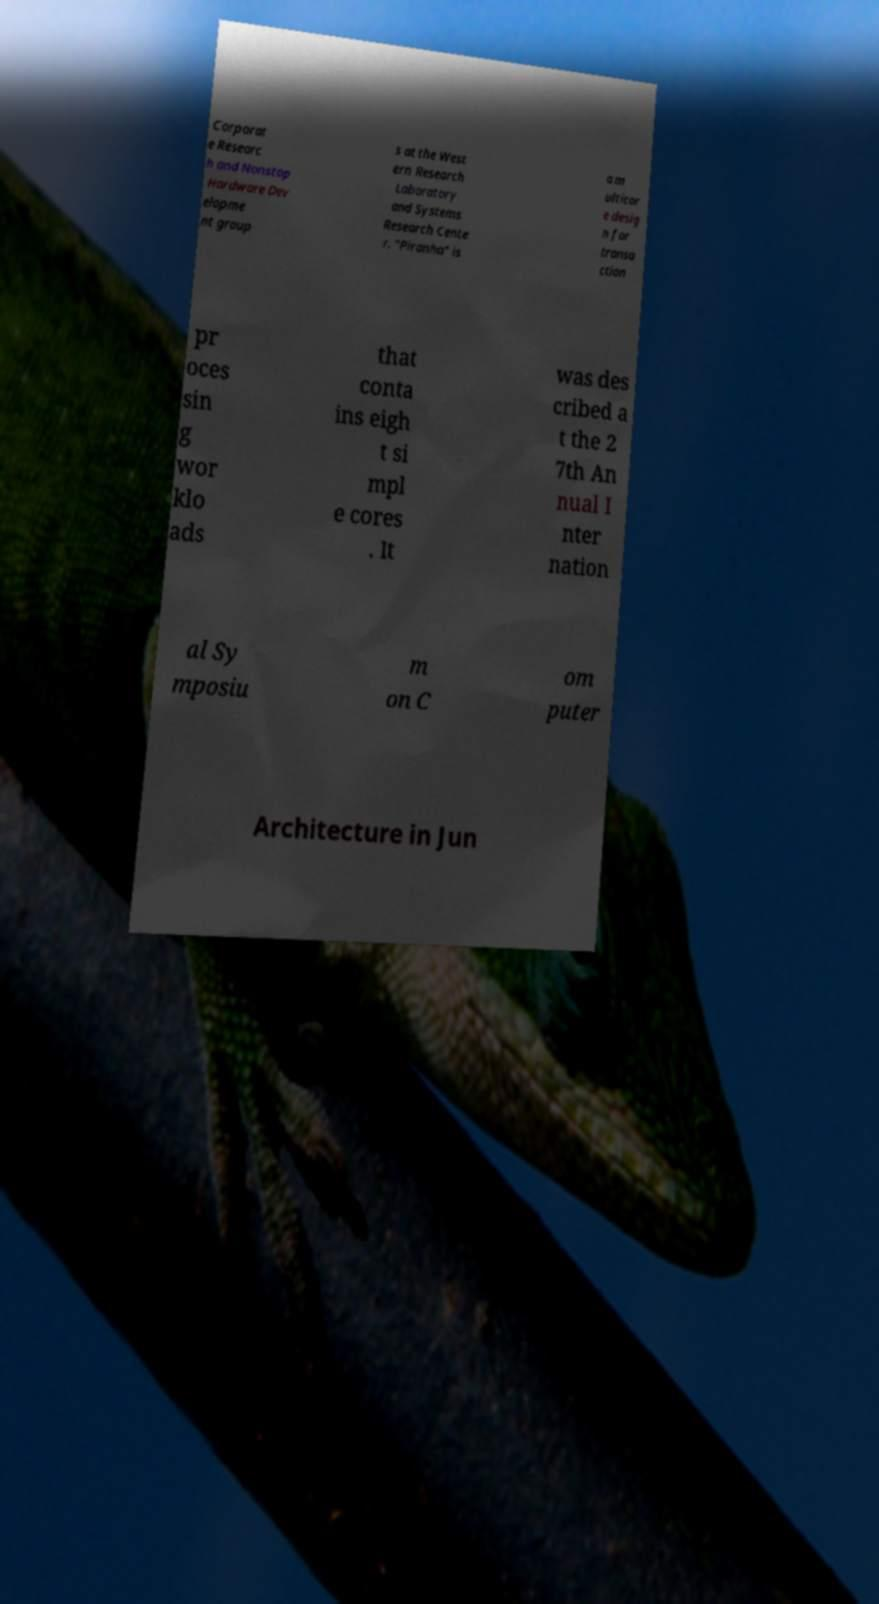I need the written content from this picture converted into text. Can you do that? Corporat e Researc h and Nonstop Hardware Dev elopme nt group s at the West ern Research Laboratory and Systems Research Cente r. "Piranha" is a m ulticor e desig n for transa ction pr oces sin g wor klo ads that conta ins eigh t si mpl e cores . It was des cribed a t the 2 7th An nual I nter nation al Sy mposiu m on C om puter Architecture in Jun 